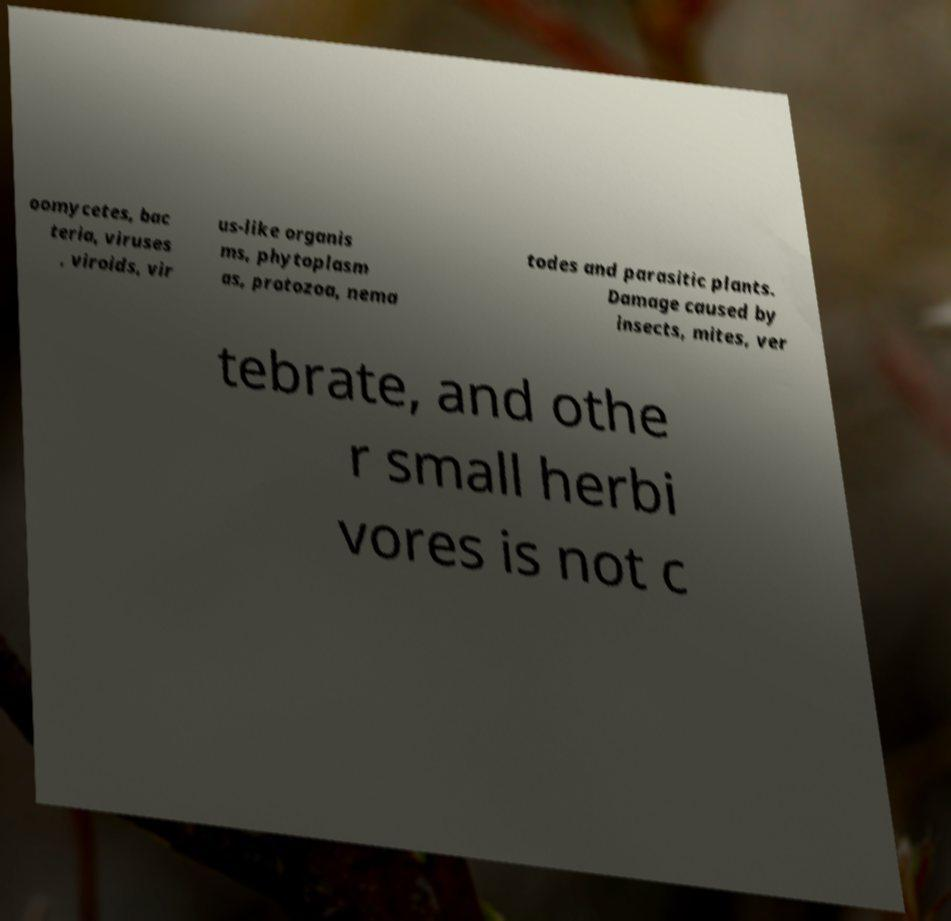Could you extract and type out the text from this image? oomycetes, bac teria, viruses , viroids, vir us-like organis ms, phytoplasm as, protozoa, nema todes and parasitic plants. Damage caused by insects, mites, ver tebrate, and othe r small herbi vores is not c 